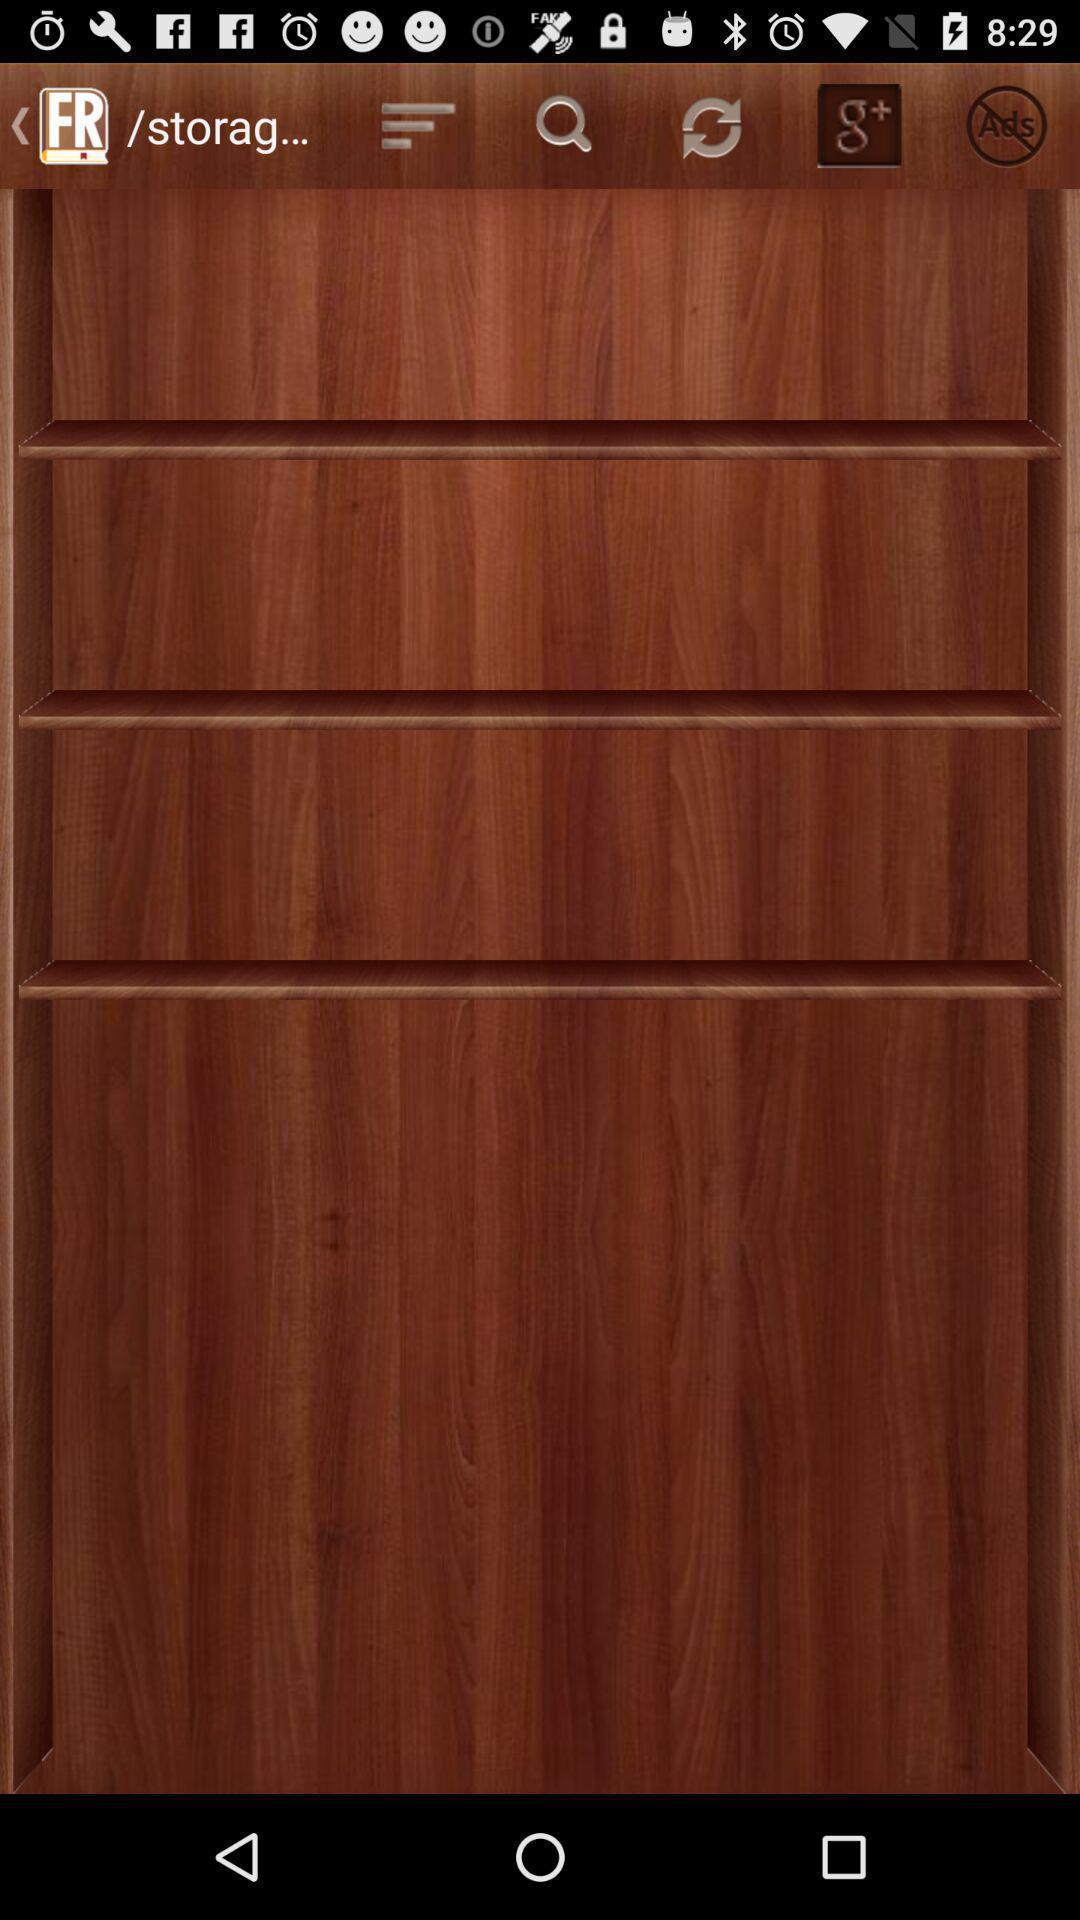Tell me what you see in this picture. Page showing e-book reader application. 